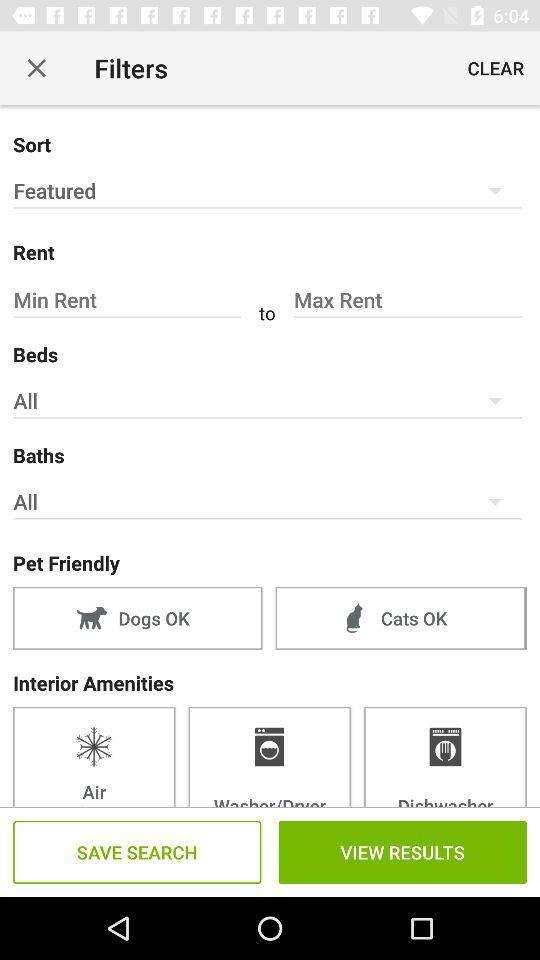How many options are there for interior amenities?
Answer the question using a single word or phrase. 3 